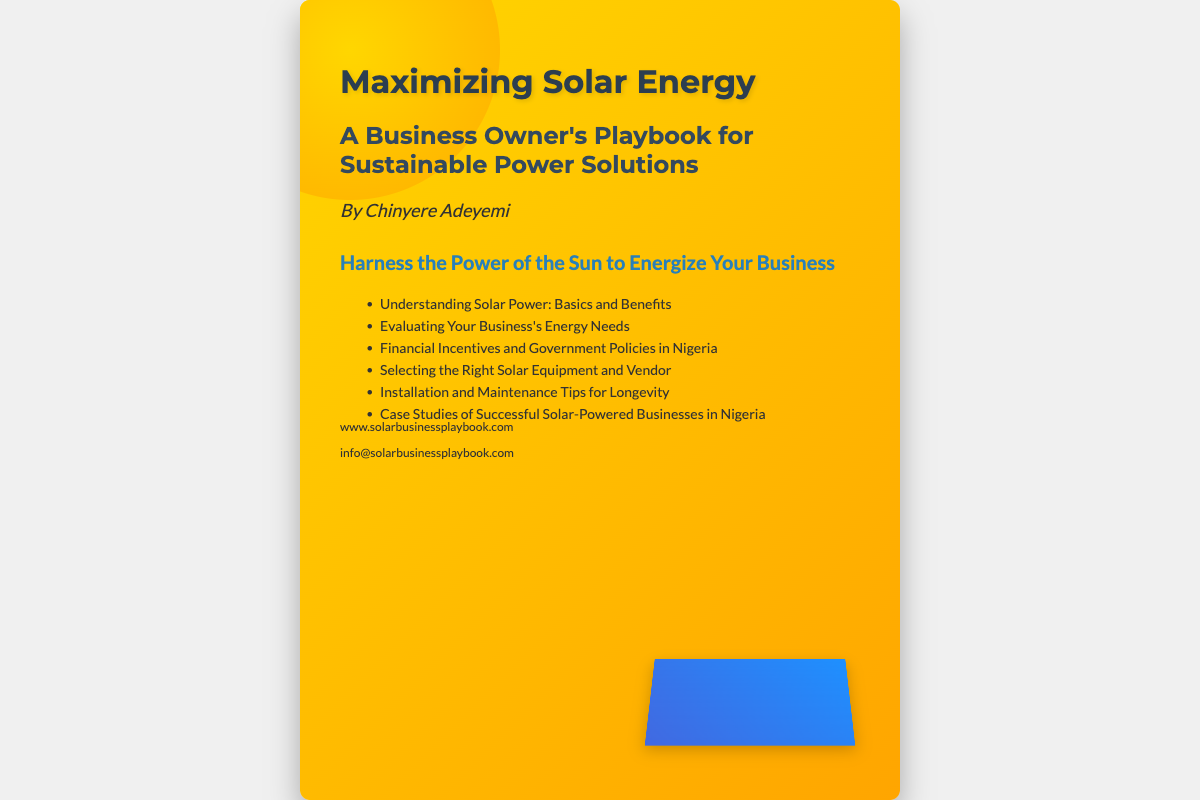What is the title of the book? The title of the book is prominently displayed on the cover.
Answer: Maximizing Solar Energy Who is the author? The author's name is listed below the title in the content section.
Answer: Chinyere Adeyemi What is the tagline of the book? The tagline is located prominently below the author's name.
Answer: Harness the Power of the Sun to Energize Your Business How many topics are listed in the book cover? The number of topics is indicated by the number of items in the topics section.
Answer: Six What is the main theme of the book? The main theme can be inferred from the title and subtitle together.
Answer: Sustainable Power Solutions What color gradient is used for the book cover background? The background color gradient is specified in the CSS styling of the cover.
Answer: Yellow to orange What type of equipment is featured prominently on the cover? The type of equipment can be inferred from the visual design elements shown on the cover.
Answer: Solar panels What information can you find at the bottom of the cover? This refers to the contact details provided at the bottom of the document.
Answer: Website and email address How is solar power beneficial for business owners according to the title? This can be understood from the subtitle, which outlines the purpose of the book.
Answer: It provides sustainable power solutions 